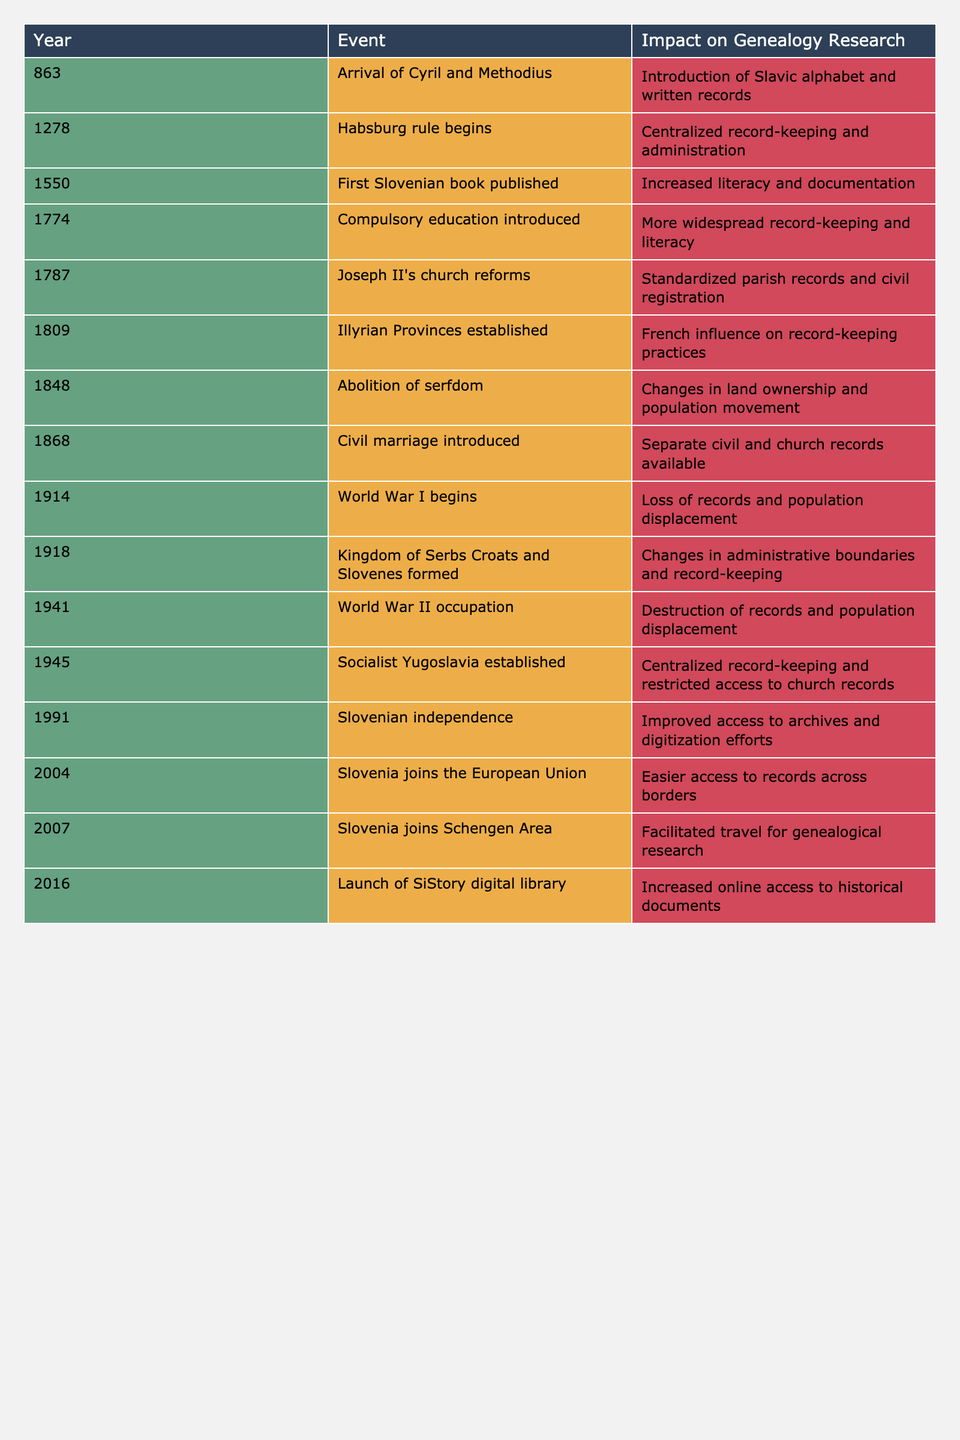What year did the introduction of compulsory education occur? According to the table, the introduction of compulsory education occurred in the year 1774.
Answer: 1774 What impact did the arrival of Cyril and Methodius have on genealogy research? The arrival of Cyril and Methodius in 863 introduced the Slavic alphabet and written records, which are crucial for genealogical documentation.
Answer: Introduction of Slavic alphabet and written records What major event occurred in 1945, and how did it affect genealogy research? In 1945, Socialist Yugoslavia was established, leading to centralized record-keeping and restricted access to church records, impacting genealogical research.
Answer: Centralized record-keeping and restricted access to church records How many historical events listed in the table occurred before the 20th century? There are 10 events listed in the table, and counting the events from 863 to 1891, we have 9 events before 1900.
Answer: 9 Did Slovenia join the Schengen Area before or after becoming independent? According to the table, Slovenia joined the Schengen Area in 2007, which is after gaining independence in 1991.
Answer: After What was the impact of the establishment of the Illyrian Provinces in 1809 on genealogy research? The establishment of the Illyrian Provinces in 1809 introduced French influence on record-keeping practices, affecting how records were maintained.
Answer: French influence on record-keeping practices How many wars are mentioned in the table, and what years do they occur? There are two wars mentioned: World War I in 1914 and World War II in 1941, totaling two wars in the table.
Answer: 2; 1914, 1941 What changes occurred in administrative boundaries and record-keeping after 1918? After 1918, when the Kingdom of Serbs Croats and Slovenes was formed, there were significant changes in administrative boundaries, which also affected record-keeping processes.
Answer: Changes in administrative boundaries and record-keeping What years mark significant changes in literacy and education, based on the table? The years that mark significant changes in literacy and education are 1550 (first Slovenian book), 1774 (compulsory education), and 1787 (church reforms).
Answer: 1550, 1774, 1787 How did the events of World War I and World War II compare in terms of impact on records? Both World War I, beginning in 1914, and World War II, beginning in 1941, led to loss and destruction of records, but the context and scale may differ.
Answer: Loss of records for both What long-term effects arose from the abolition of serfdom in 1848? The abolition of serfdom in 1848 led to changes in land ownership and population movement, which would affect genealogical records regarding property and family relations.
Answer: Changes in land ownership and population movement 